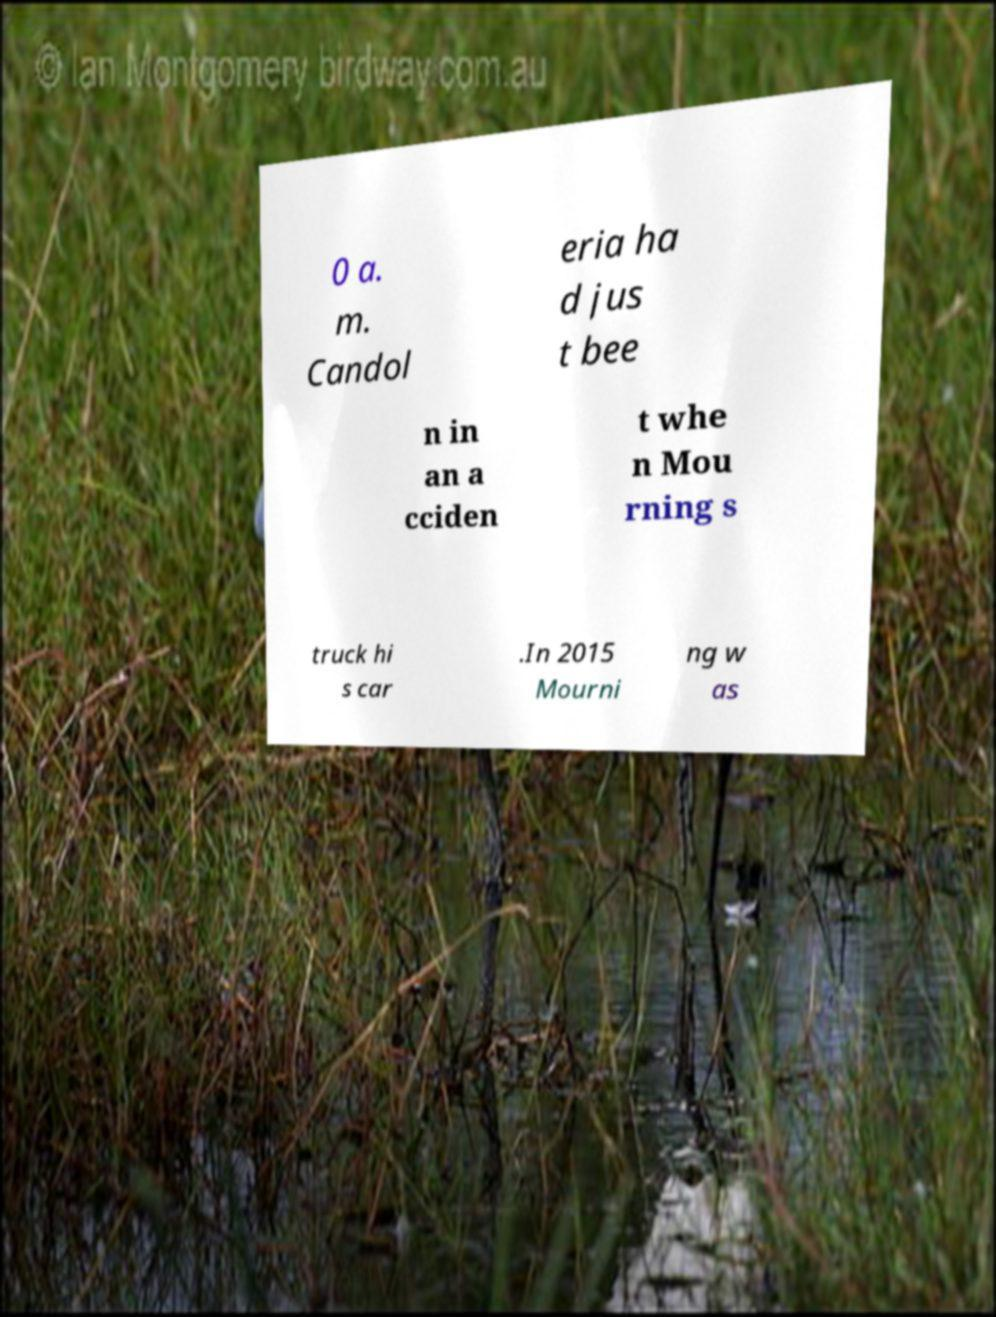Please identify and transcribe the text found in this image. 0 a. m. Candol eria ha d jus t bee n in an a cciden t whe n Mou rning s truck hi s car .In 2015 Mourni ng w as 